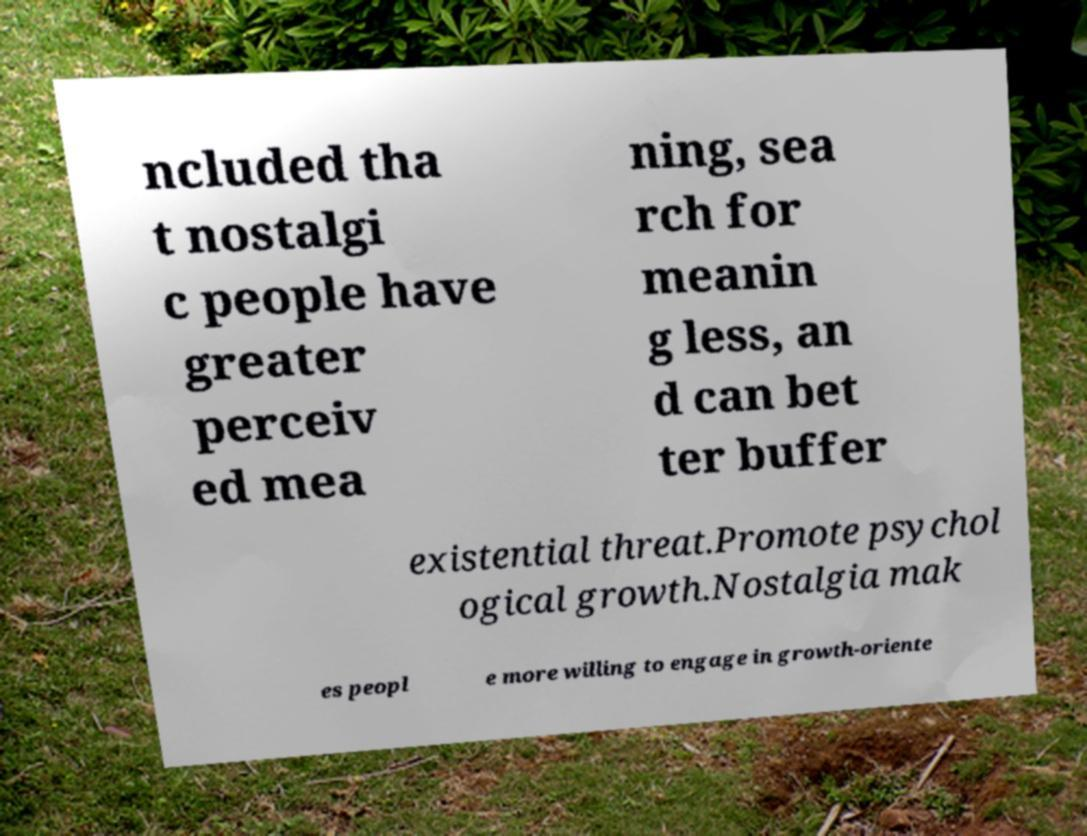Can you read and provide the text displayed in the image?This photo seems to have some interesting text. Can you extract and type it out for me? ncluded tha t nostalgi c people have greater perceiv ed mea ning, sea rch for meanin g less, an d can bet ter buffer existential threat.Promote psychol ogical growth.Nostalgia mak es peopl e more willing to engage in growth-oriente 